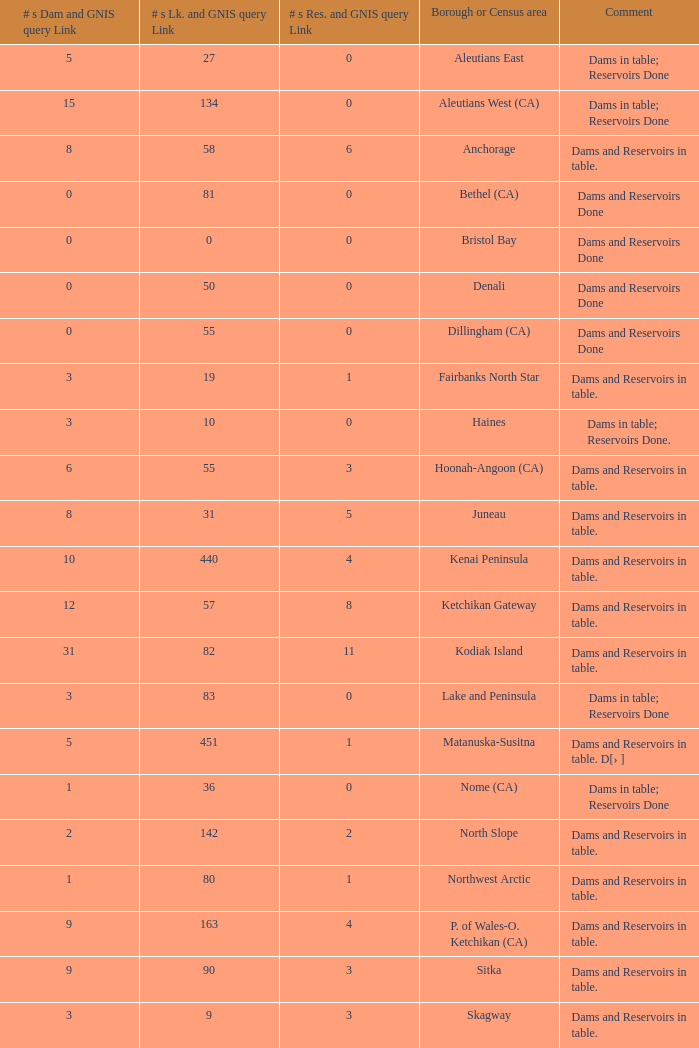Name the most numbers dam and gnis query link for borough or census area for fairbanks north star 3.0. 